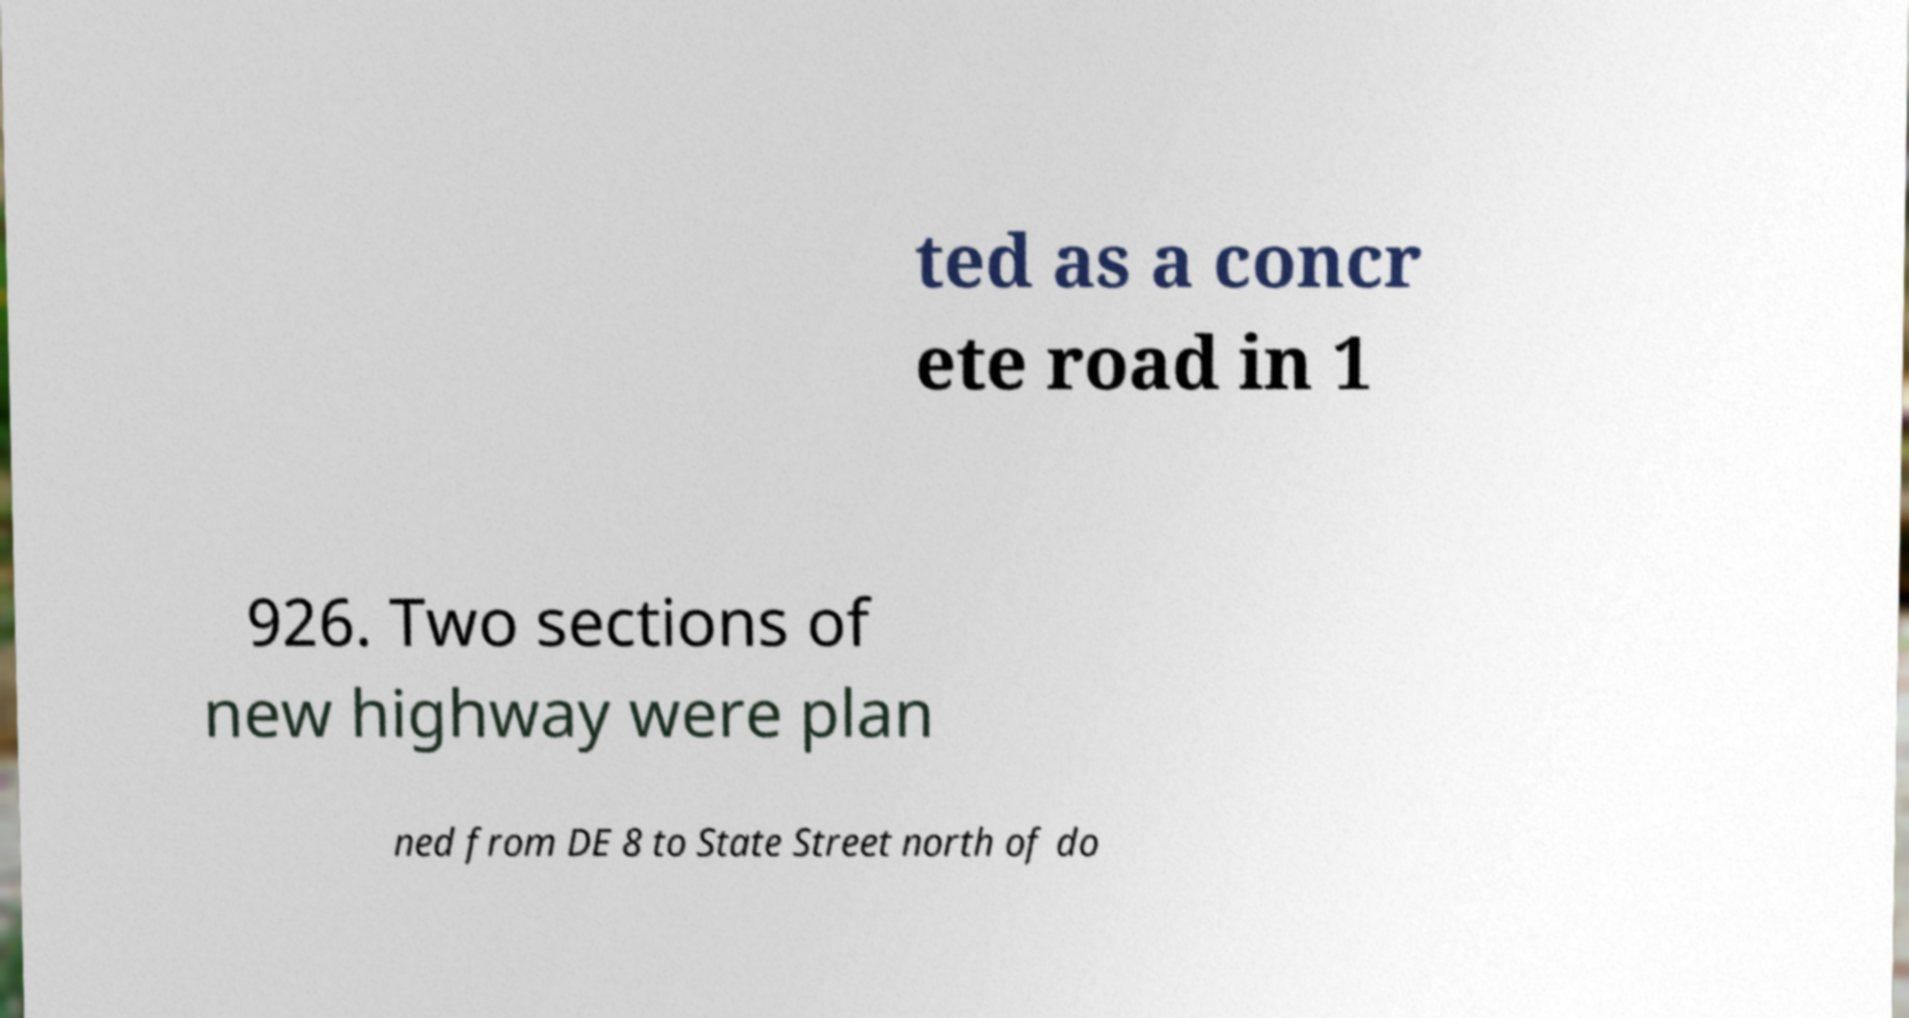Can you read and provide the text displayed in the image?This photo seems to have some interesting text. Can you extract and type it out for me? ted as a concr ete road in 1 926. Two sections of new highway were plan ned from DE 8 to State Street north of do 